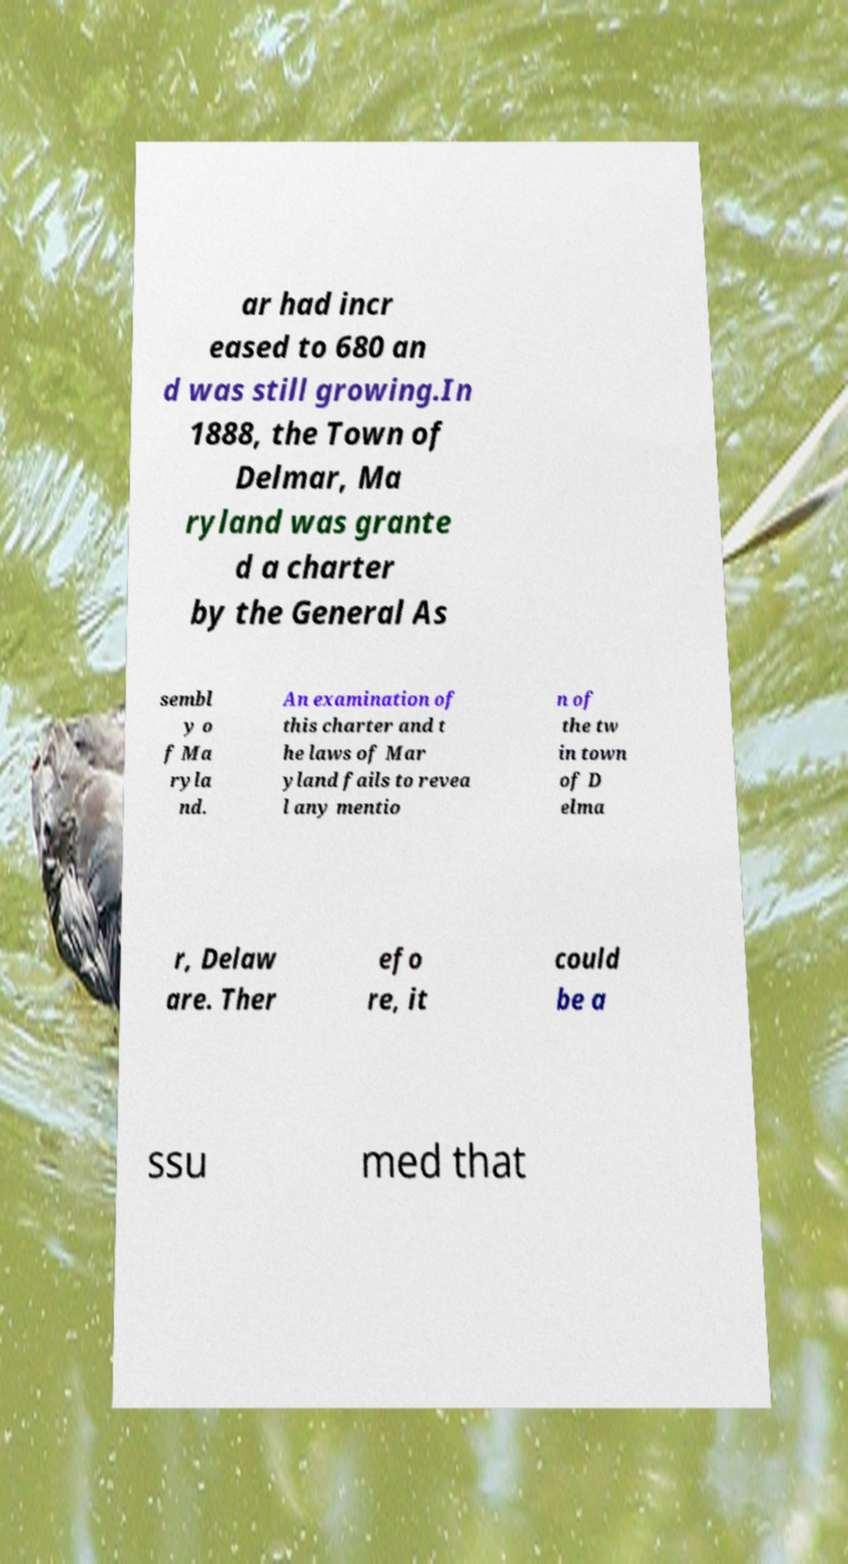Can you read and provide the text displayed in the image?This photo seems to have some interesting text. Can you extract and type it out for me? ar had incr eased to 680 an d was still growing.In 1888, the Town of Delmar, Ma ryland was grante d a charter by the General As sembl y o f Ma ryla nd. An examination of this charter and t he laws of Mar yland fails to revea l any mentio n of the tw in town of D elma r, Delaw are. Ther efo re, it could be a ssu med that 